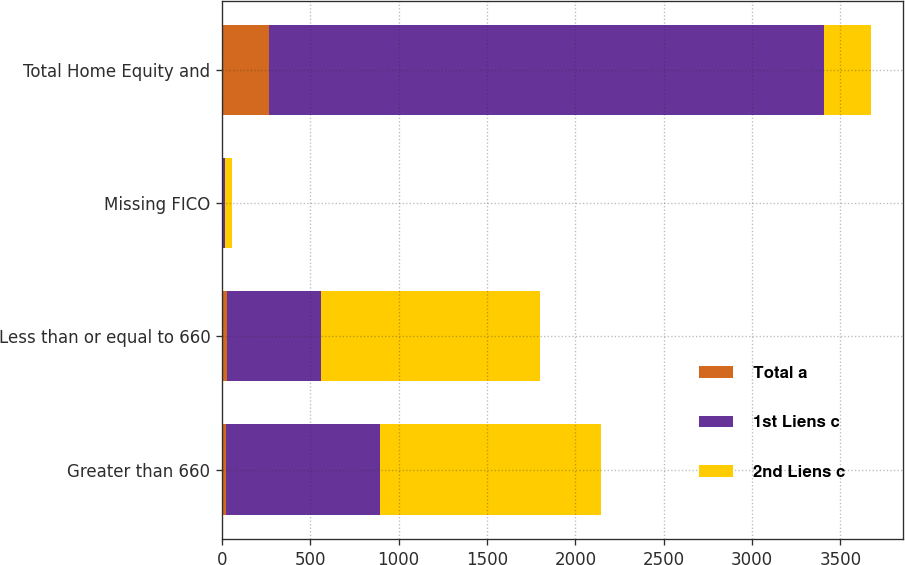Convert chart. <chart><loc_0><loc_0><loc_500><loc_500><stacked_bar_chart><ecel><fcel>Greater than 660<fcel>Less than or equal to 660<fcel>Missing FICO<fcel>Total Home Equity and<nl><fcel>Total a<fcel>21<fcel>28<fcel>1<fcel>268<nl><fcel>1st Liens c<fcel>871<fcel>532<fcel>16<fcel>3137<nl><fcel>2nd Liens c<fcel>1253<fcel>1241<fcel>39<fcel>268<nl></chart> 